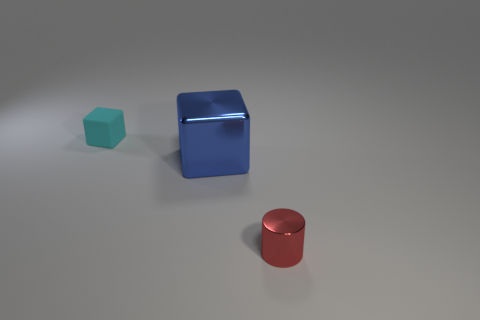Add 2 tiny yellow shiny cylinders. How many objects exist? 5 Subtract all blocks. How many objects are left? 1 Add 3 cyan rubber blocks. How many cyan rubber blocks exist? 4 Subtract 1 blue blocks. How many objects are left? 2 Subtract all tiny brown matte blocks. Subtract all cyan matte objects. How many objects are left? 2 Add 1 large shiny cubes. How many large shiny cubes are left? 2 